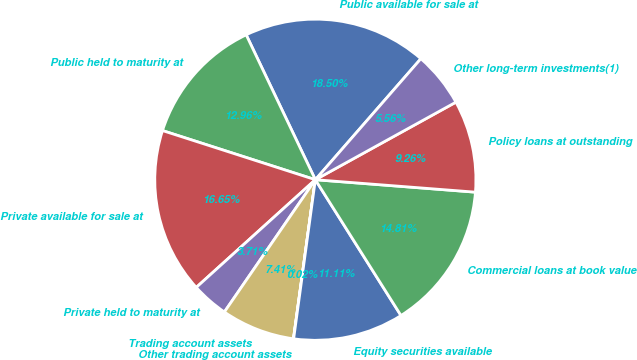Convert chart. <chart><loc_0><loc_0><loc_500><loc_500><pie_chart><fcel>Public available for sale at<fcel>Public held to maturity at<fcel>Private available for sale at<fcel>Private held to maturity at<fcel>Trading account assets<fcel>Other trading account assets<fcel>Equity securities available<fcel>Commercial loans at book value<fcel>Policy loans at outstanding<fcel>Other long-term investments(1)<nl><fcel>18.5%<fcel>12.96%<fcel>16.65%<fcel>3.71%<fcel>7.41%<fcel>0.02%<fcel>11.11%<fcel>14.81%<fcel>9.26%<fcel>5.56%<nl></chart> 